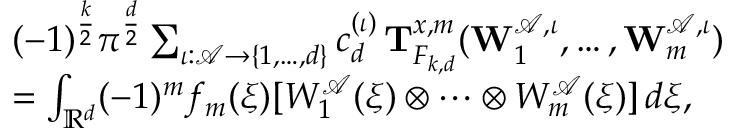Convert formula to latex. <formula><loc_0><loc_0><loc_500><loc_500>\begin{array} { r l } & { ( - 1 ) ^ { \frac { k } { 2 } } \pi ^ { \frac { d } { 2 } } \sum _ { \iota \colon \ m a t h s c r { A } \to \{ 1 , \dots , d \} } c _ { d } ^ { ( \iota ) } \, \mathbf T _ { F _ { k , d } } ^ { x , m } ( \mathbf W _ { 1 } ^ { \ m a t h s c r { A } , \iota } , \dots , \mathbf W _ { m } ^ { \ m a t h s c r { A } , \iota } ) } \\ & { = \int _ { \mathbb { R } ^ { d } } ( - 1 ) ^ { m } f _ { m } ( \xi ) [ W _ { 1 } ^ { \ m a t h s c r A } ( \xi ) \otimes \cdots \otimes W _ { m } ^ { \ m a t h s c r A } ( \xi ) ] \, d \xi , } \end{array}</formula> 